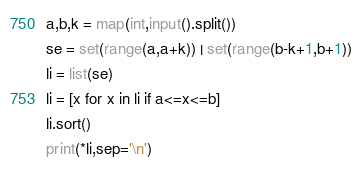<code> <loc_0><loc_0><loc_500><loc_500><_Python_>a,b,k = map(int,input().split())
se = set(range(a,a+k)) | set(range(b-k+1,b+1))
li = list(se)
li = [x for x in li if a<=x<=b]
li.sort()
print(*li,sep='\n')
</code> 